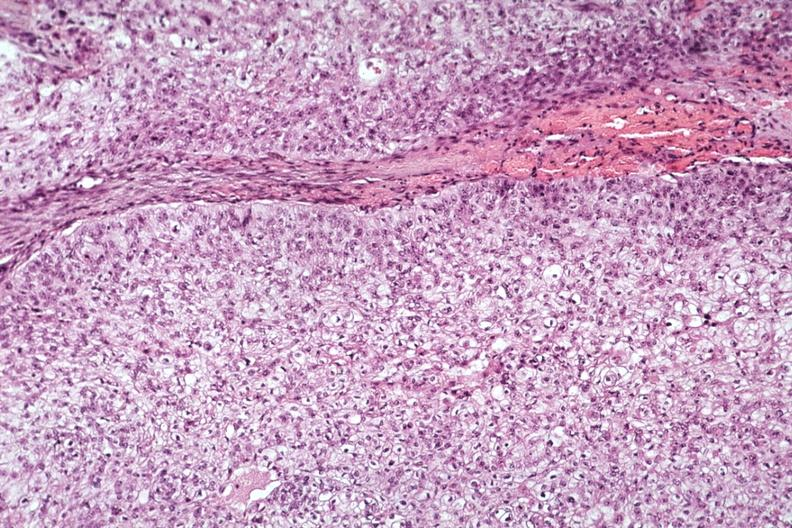what is present?
Answer the question using a single word or phrase. Parathyroid 